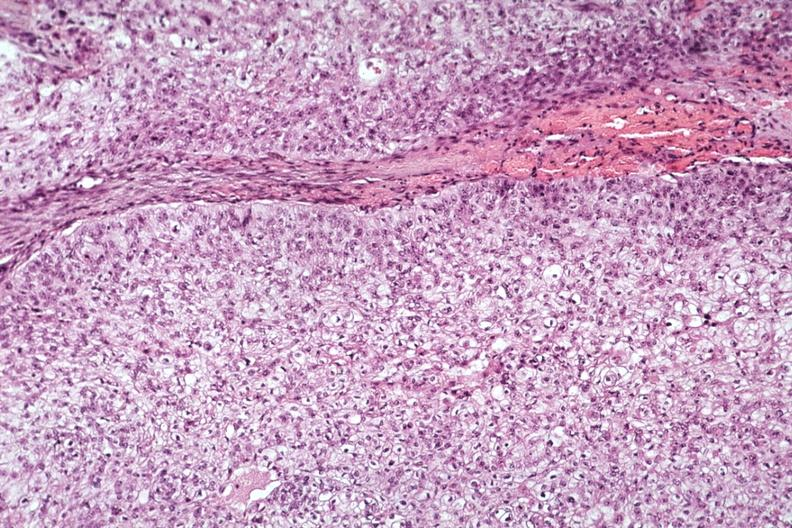what is present?
Answer the question using a single word or phrase. Parathyroid 